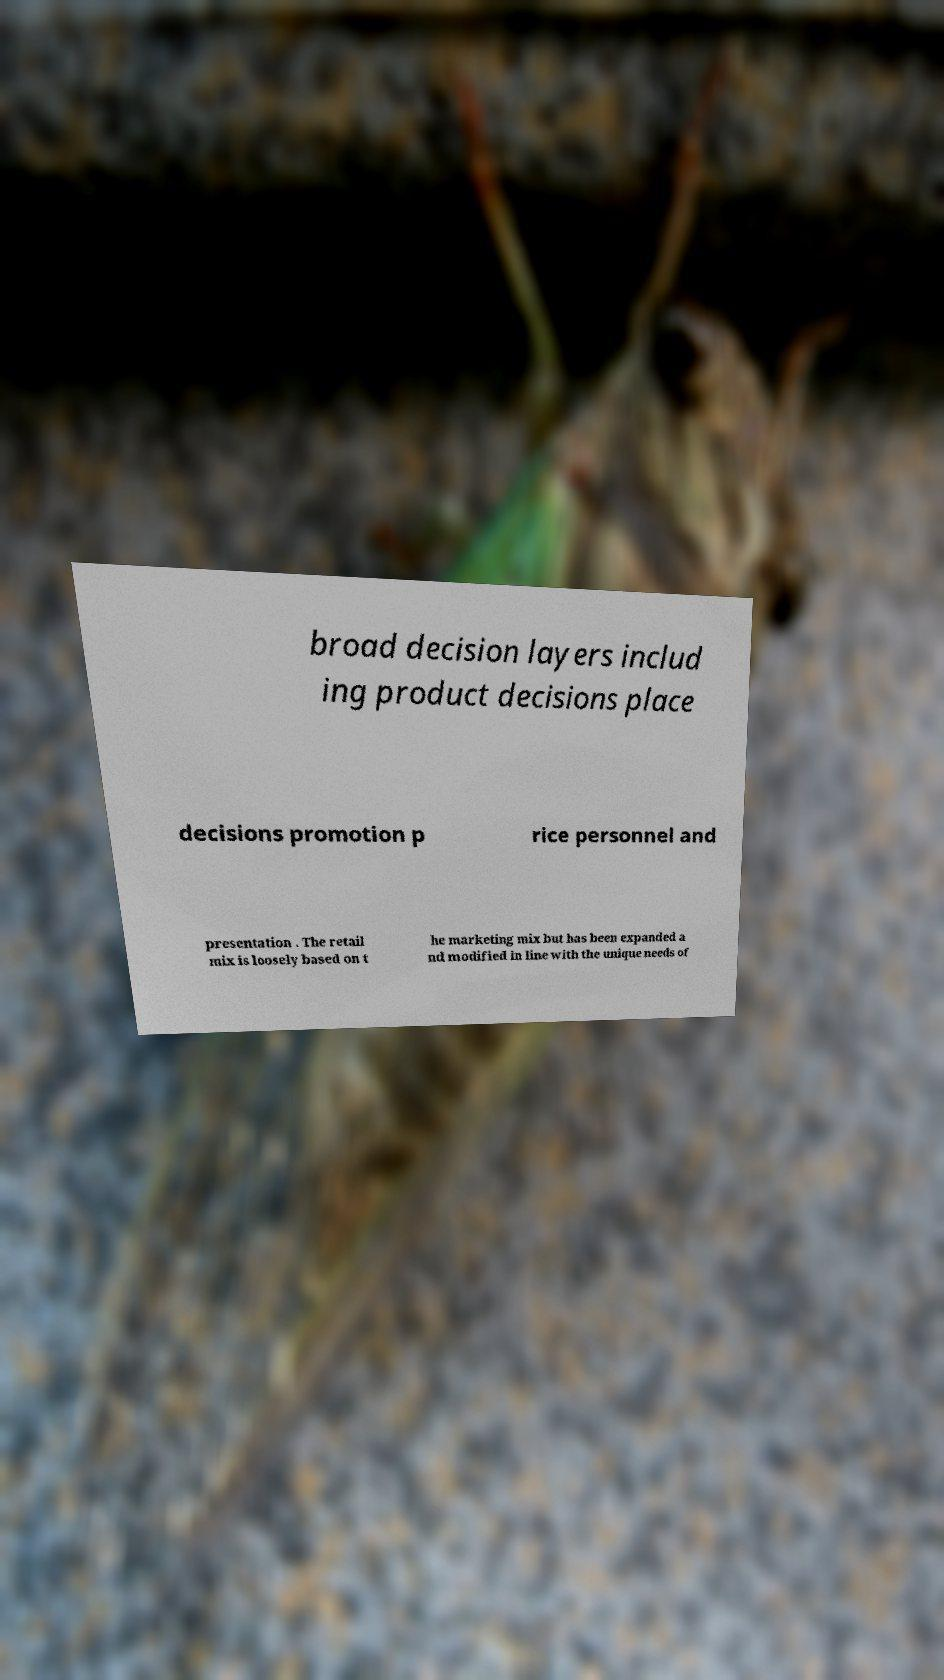For documentation purposes, I need the text within this image transcribed. Could you provide that? broad decision layers includ ing product decisions place decisions promotion p rice personnel and presentation . The retail mix is loosely based on t he marketing mix but has been expanded a nd modified in line with the unique needs of 